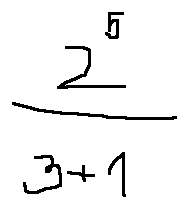Convert formula to latex. <formula><loc_0><loc_0><loc_500><loc_500>\frac { 2 ^ { 5 } } { 3 + 1 }</formula> 